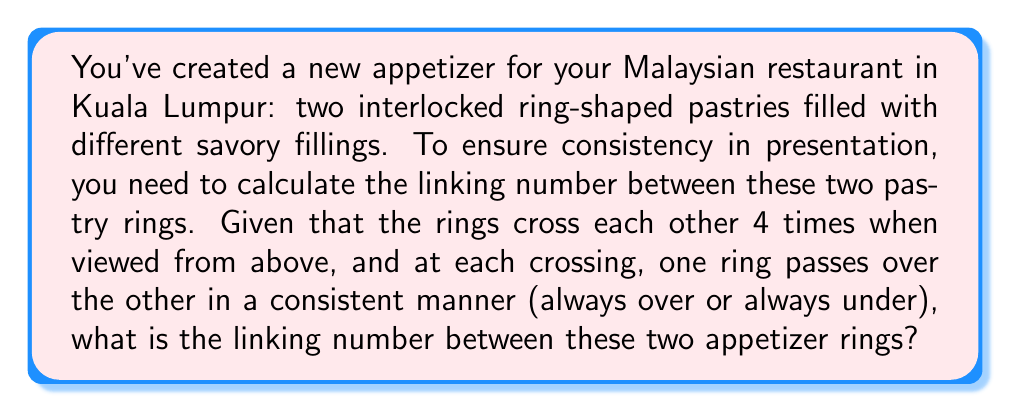Provide a solution to this math problem. To calculate the linking number between two interlocked rings, we follow these steps:

1. Assign an orientation to each ring. Let's assume we orient both rings clockwise when viewed from above.

2. At each crossing, assign a value of +1 or -1 based on the right-hand rule:
   - If the top strand's direction and the bottom strand's direction form a right-handed screw, assign +1.
   - If they form a left-handed screw, assign -1.

3. Sum up these values for all crossings.

4. Divide the sum by 2 to get the linking number.

In this case:
- We have 4 crossings.
- One ring consistently passes over the other at all crossings.
- With clockwise orientation for both rings, all crossings will have the same sign.

Let's assume the crossings are all +1 (if they were all -1, the magnitude of the result would be the same).

$$ \text{Linking Number} = \frac{1}{2} \sum_{i=1}^{4} \text{sign}(\text{crossing}_i) $$

$$ = \frac{1}{2} (1 + 1 + 1 + 1) = \frac{1}{2} (4) = 2 $$

Therefore, the linking number between the two appetizer rings is 2 or -2, depending on how we chose the orientations.
Answer: $\pm 2$ 